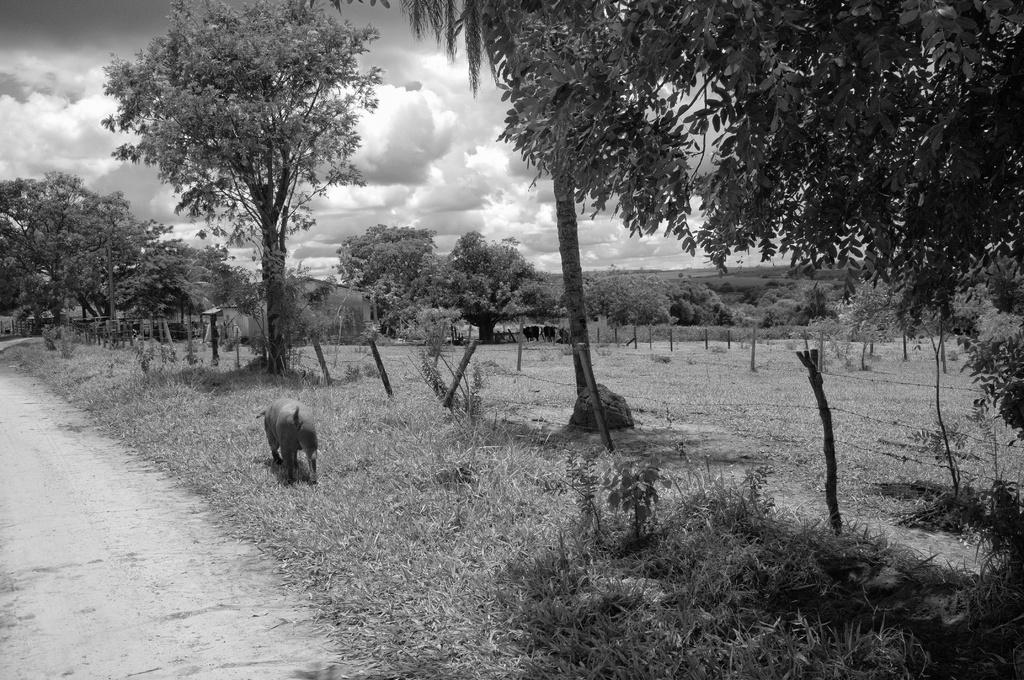What is the color scheme of the image? The image is black and white. What is the animal walking on in the image? The animal is walking on the grass. What type of structures can be seen in the image? There are fences in the image. What type of natural elements are present in the image? There are trees and plants in the image. Are there any other living creatures in the image besides the animal walking on the grass? Yes, there are other animals in the image. What can be seen in the sky in the image? There are clouds in the sky. Where is the school located in the image? There is no school present in the image. What type of glue is being used by the animals in the image? There is no glue or any indication of its use in the image. 